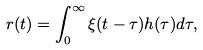Convert formula to latex. <formula><loc_0><loc_0><loc_500><loc_500>r ( t ) = \int _ { 0 } ^ { \infty } \xi ( t - \tau ) h ( \tau ) d \tau ,</formula> 